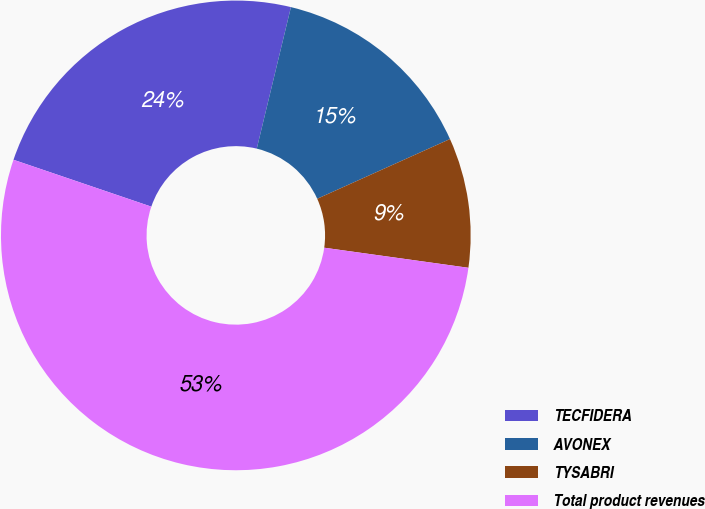Convert chart. <chart><loc_0><loc_0><loc_500><loc_500><pie_chart><fcel>TECFIDERA<fcel>AVONEX<fcel>TYSABRI<fcel>Total product revenues<nl><fcel>23.55%<fcel>14.5%<fcel>8.93%<fcel>53.01%<nl></chart> 